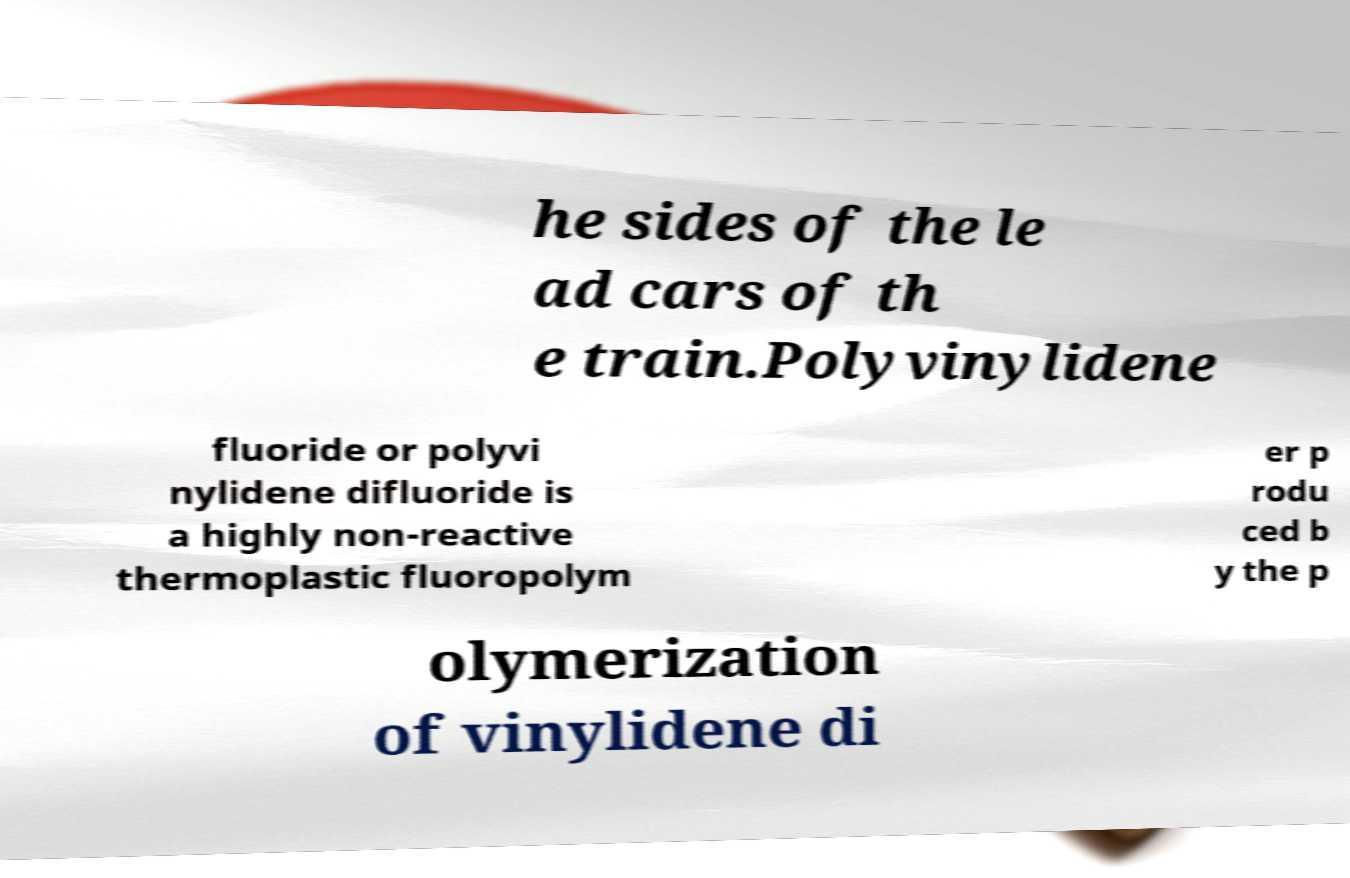Can you read and provide the text displayed in the image?This photo seems to have some interesting text. Can you extract and type it out for me? he sides of the le ad cars of th e train.Polyvinylidene fluoride or polyvi nylidene difluoride is a highly non-reactive thermoplastic fluoropolym er p rodu ced b y the p olymerization of vinylidene di 